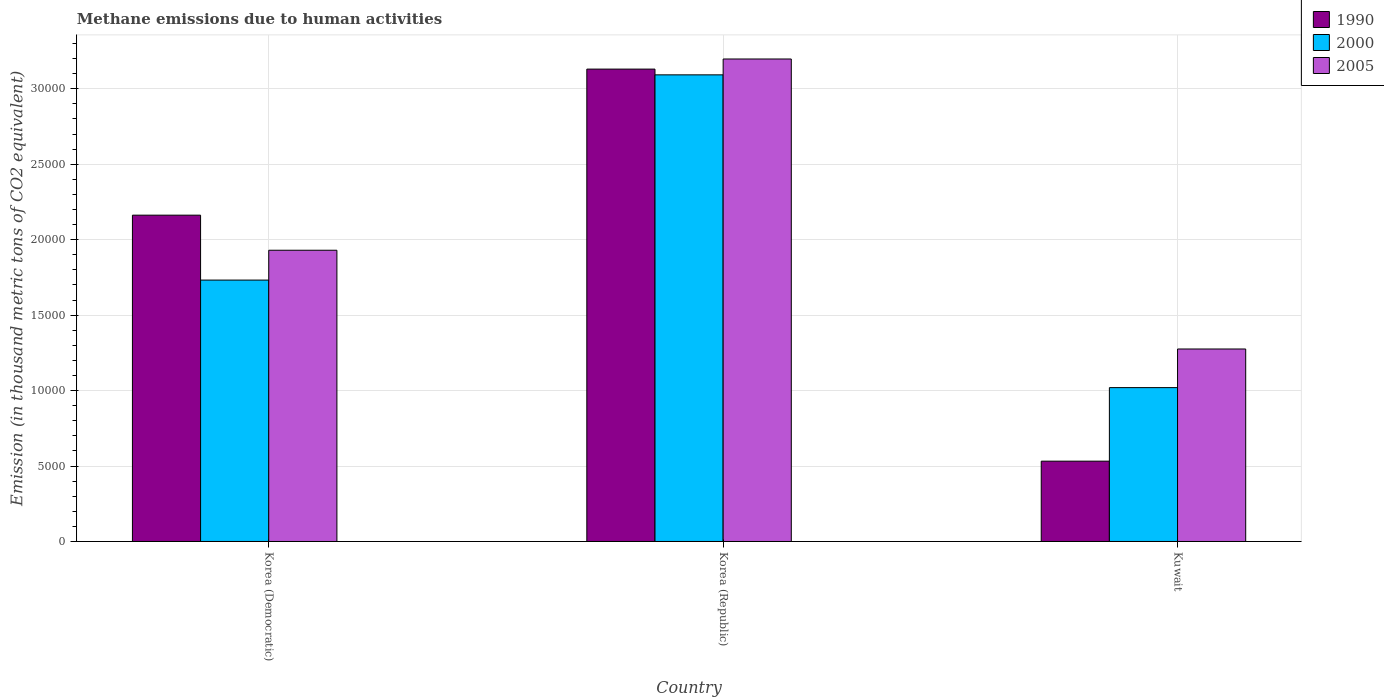How many different coloured bars are there?
Provide a succinct answer. 3. Are the number of bars per tick equal to the number of legend labels?
Keep it short and to the point. Yes. Are the number of bars on each tick of the X-axis equal?
Give a very brief answer. Yes. How many bars are there on the 3rd tick from the left?
Ensure brevity in your answer.  3. What is the label of the 3rd group of bars from the left?
Make the answer very short. Kuwait. What is the amount of methane emitted in 1990 in Korea (Republic)?
Provide a succinct answer. 3.13e+04. Across all countries, what is the maximum amount of methane emitted in 2005?
Your answer should be very brief. 3.20e+04. Across all countries, what is the minimum amount of methane emitted in 2000?
Provide a short and direct response. 1.02e+04. In which country was the amount of methane emitted in 2005 minimum?
Offer a very short reply. Kuwait. What is the total amount of methane emitted in 2005 in the graph?
Your answer should be very brief. 6.40e+04. What is the difference between the amount of methane emitted in 1990 in Korea (Democratic) and that in Korea (Republic)?
Ensure brevity in your answer.  -9680.3. What is the difference between the amount of methane emitted in 2000 in Kuwait and the amount of methane emitted in 2005 in Korea (Democratic)?
Provide a succinct answer. -9104.1. What is the average amount of methane emitted in 1990 per country?
Offer a terse response. 1.94e+04. What is the difference between the amount of methane emitted of/in 1990 and amount of methane emitted of/in 2000 in Korea (Democratic)?
Make the answer very short. 4301.8. In how many countries, is the amount of methane emitted in 1990 greater than 8000 thousand metric tons?
Provide a short and direct response. 2. What is the ratio of the amount of methane emitted in 2005 in Korea (Democratic) to that in Kuwait?
Ensure brevity in your answer.  1.51. Is the difference between the amount of methane emitted in 1990 in Korea (Democratic) and Kuwait greater than the difference between the amount of methane emitted in 2000 in Korea (Democratic) and Kuwait?
Provide a short and direct response. Yes. What is the difference between the highest and the second highest amount of methane emitted in 1990?
Provide a short and direct response. -9680.3. What is the difference between the highest and the lowest amount of methane emitted in 2005?
Your answer should be very brief. 1.92e+04. Is the sum of the amount of methane emitted in 2005 in Korea (Democratic) and Kuwait greater than the maximum amount of methane emitted in 2000 across all countries?
Keep it short and to the point. Yes. What does the 3rd bar from the left in Korea (Democratic) represents?
Ensure brevity in your answer.  2005. What does the 3rd bar from the right in Korea (Democratic) represents?
Your answer should be compact. 1990. How many bars are there?
Your response must be concise. 9. How many countries are there in the graph?
Make the answer very short. 3. What is the difference between two consecutive major ticks on the Y-axis?
Your answer should be compact. 5000. Are the values on the major ticks of Y-axis written in scientific E-notation?
Keep it short and to the point. No. Does the graph contain any zero values?
Ensure brevity in your answer.  No. Where does the legend appear in the graph?
Keep it short and to the point. Top right. How are the legend labels stacked?
Your answer should be very brief. Vertical. What is the title of the graph?
Your answer should be very brief. Methane emissions due to human activities. Does "1999" appear as one of the legend labels in the graph?
Your answer should be very brief. No. What is the label or title of the Y-axis?
Offer a terse response. Emission (in thousand metric tons of CO2 equivalent). What is the Emission (in thousand metric tons of CO2 equivalent) of 1990 in Korea (Democratic)?
Ensure brevity in your answer.  2.16e+04. What is the Emission (in thousand metric tons of CO2 equivalent) in 2000 in Korea (Democratic)?
Offer a terse response. 1.73e+04. What is the Emission (in thousand metric tons of CO2 equivalent) in 2005 in Korea (Democratic)?
Offer a terse response. 1.93e+04. What is the Emission (in thousand metric tons of CO2 equivalent) in 1990 in Korea (Republic)?
Make the answer very short. 3.13e+04. What is the Emission (in thousand metric tons of CO2 equivalent) in 2000 in Korea (Republic)?
Offer a very short reply. 3.09e+04. What is the Emission (in thousand metric tons of CO2 equivalent) in 2005 in Korea (Republic)?
Provide a succinct answer. 3.20e+04. What is the Emission (in thousand metric tons of CO2 equivalent) of 1990 in Kuwait?
Your response must be concise. 5323.1. What is the Emission (in thousand metric tons of CO2 equivalent) in 2000 in Kuwait?
Your answer should be very brief. 1.02e+04. What is the Emission (in thousand metric tons of CO2 equivalent) in 2005 in Kuwait?
Your answer should be compact. 1.28e+04. Across all countries, what is the maximum Emission (in thousand metric tons of CO2 equivalent) of 1990?
Keep it short and to the point. 3.13e+04. Across all countries, what is the maximum Emission (in thousand metric tons of CO2 equivalent) of 2000?
Provide a short and direct response. 3.09e+04. Across all countries, what is the maximum Emission (in thousand metric tons of CO2 equivalent) of 2005?
Keep it short and to the point. 3.20e+04. Across all countries, what is the minimum Emission (in thousand metric tons of CO2 equivalent) in 1990?
Ensure brevity in your answer.  5323.1. Across all countries, what is the minimum Emission (in thousand metric tons of CO2 equivalent) in 2000?
Offer a very short reply. 1.02e+04. Across all countries, what is the minimum Emission (in thousand metric tons of CO2 equivalent) in 2005?
Give a very brief answer. 1.28e+04. What is the total Emission (in thousand metric tons of CO2 equivalent) in 1990 in the graph?
Provide a succinct answer. 5.83e+04. What is the total Emission (in thousand metric tons of CO2 equivalent) of 2000 in the graph?
Give a very brief answer. 5.84e+04. What is the total Emission (in thousand metric tons of CO2 equivalent) of 2005 in the graph?
Provide a short and direct response. 6.40e+04. What is the difference between the Emission (in thousand metric tons of CO2 equivalent) of 1990 in Korea (Democratic) and that in Korea (Republic)?
Your answer should be very brief. -9680.3. What is the difference between the Emission (in thousand metric tons of CO2 equivalent) in 2000 in Korea (Democratic) and that in Korea (Republic)?
Make the answer very short. -1.36e+04. What is the difference between the Emission (in thousand metric tons of CO2 equivalent) of 2005 in Korea (Democratic) and that in Korea (Republic)?
Give a very brief answer. -1.27e+04. What is the difference between the Emission (in thousand metric tons of CO2 equivalent) of 1990 in Korea (Democratic) and that in Kuwait?
Your answer should be very brief. 1.63e+04. What is the difference between the Emission (in thousand metric tons of CO2 equivalent) in 2000 in Korea (Democratic) and that in Kuwait?
Give a very brief answer. 7127.1. What is the difference between the Emission (in thousand metric tons of CO2 equivalent) in 2005 in Korea (Democratic) and that in Kuwait?
Your answer should be compact. 6544.1. What is the difference between the Emission (in thousand metric tons of CO2 equivalent) of 1990 in Korea (Republic) and that in Kuwait?
Ensure brevity in your answer.  2.60e+04. What is the difference between the Emission (in thousand metric tons of CO2 equivalent) in 2000 in Korea (Republic) and that in Kuwait?
Keep it short and to the point. 2.07e+04. What is the difference between the Emission (in thousand metric tons of CO2 equivalent) in 2005 in Korea (Republic) and that in Kuwait?
Your response must be concise. 1.92e+04. What is the difference between the Emission (in thousand metric tons of CO2 equivalent) in 1990 in Korea (Democratic) and the Emission (in thousand metric tons of CO2 equivalent) in 2000 in Korea (Republic)?
Offer a terse response. -9299.2. What is the difference between the Emission (in thousand metric tons of CO2 equivalent) in 1990 in Korea (Democratic) and the Emission (in thousand metric tons of CO2 equivalent) in 2005 in Korea (Republic)?
Make the answer very short. -1.04e+04. What is the difference between the Emission (in thousand metric tons of CO2 equivalent) of 2000 in Korea (Democratic) and the Emission (in thousand metric tons of CO2 equivalent) of 2005 in Korea (Republic)?
Your answer should be very brief. -1.47e+04. What is the difference between the Emission (in thousand metric tons of CO2 equivalent) of 1990 in Korea (Democratic) and the Emission (in thousand metric tons of CO2 equivalent) of 2000 in Kuwait?
Offer a terse response. 1.14e+04. What is the difference between the Emission (in thousand metric tons of CO2 equivalent) in 1990 in Korea (Democratic) and the Emission (in thousand metric tons of CO2 equivalent) in 2005 in Kuwait?
Keep it short and to the point. 8868.9. What is the difference between the Emission (in thousand metric tons of CO2 equivalent) in 2000 in Korea (Democratic) and the Emission (in thousand metric tons of CO2 equivalent) in 2005 in Kuwait?
Ensure brevity in your answer.  4567.1. What is the difference between the Emission (in thousand metric tons of CO2 equivalent) of 1990 in Korea (Republic) and the Emission (in thousand metric tons of CO2 equivalent) of 2000 in Kuwait?
Provide a short and direct response. 2.11e+04. What is the difference between the Emission (in thousand metric tons of CO2 equivalent) in 1990 in Korea (Republic) and the Emission (in thousand metric tons of CO2 equivalent) in 2005 in Kuwait?
Your answer should be very brief. 1.85e+04. What is the difference between the Emission (in thousand metric tons of CO2 equivalent) in 2000 in Korea (Republic) and the Emission (in thousand metric tons of CO2 equivalent) in 2005 in Kuwait?
Offer a very short reply. 1.82e+04. What is the average Emission (in thousand metric tons of CO2 equivalent) of 1990 per country?
Offer a terse response. 1.94e+04. What is the average Emission (in thousand metric tons of CO2 equivalent) in 2000 per country?
Give a very brief answer. 1.95e+04. What is the average Emission (in thousand metric tons of CO2 equivalent) of 2005 per country?
Provide a succinct answer. 2.13e+04. What is the difference between the Emission (in thousand metric tons of CO2 equivalent) in 1990 and Emission (in thousand metric tons of CO2 equivalent) in 2000 in Korea (Democratic)?
Your answer should be very brief. 4301.8. What is the difference between the Emission (in thousand metric tons of CO2 equivalent) of 1990 and Emission (in thousand metric tons of CO2 equivalent) of 2005 in Korea (Democratic)?
Provide a short and direct response. 2324.8. What is the difference between the Emission (in thousand metric tons of CO2 equivalent) of 2000 and Emission (in thousand metric tons of CO2 equivalent) of 2005 in Korea (Democratic)?
Ensure brevity in your answer.  -1977. What is the difference between the Emission (in thousand metric tons of CO2 equivalent) in 1990 and Emission (in thousand metric tons of CO2 equivalent) in 2000 in Korea (Republic)?
Keep it short and to the point. 381.1. What is the difference between the Emission (in thousand metric tons of CO2 equivalent) of 1990 and Emission (in thousand metric tons of CO2 equivalent) of 2005 in Korea (Republic)?
Ensure brevity in your answer.  -669.8. What is the difference between the Emission (in thousand metric tons of CO2 equivalent) in 2000 and Emission (in thousand metric tons of CO2 equivalent) in 2005 in Korea (Republic)?
Ensure brevity in your answer.  -1050.9. What is the difference between the Emission (in thousand metric tons of CO2 equivalent) in 1990 and Emission (in thousand metric tons of CO2 equivalent) in 2000 in Kuwait?
Provide a short and direct response. -4873.7. What is the difference between the Emission (in thousand metric tons of CO2 equivalent) of 1990 and Emission (in thousand metric tons of CO2 equivalent) of 2005 in Kuwait?
Offer a very short reply. -7433.7. What is the difference between the Emission (in thousand metric tons of CO2 equivalent) in 2000 and Emission (in thousand metric tons of CO2 equivalent) in 2005 in Kuwait?
Provide a short and direct response. -2560. What is the ratio of the Emission (in thousand metric tons of CO2 equivalent) of 1990 in Korea (Democratic) to that in Korea (Republic)?
Provide a short and direct response. 0.69. What is the ratio of the Emission (in thousand metric tons of CO2 equivalent) in 2000 in Korea (Democratic) to that in Korea (Republic)?
Your answer should be very brief. 0.56. What is the ratio of the Emission (in thousand metric tons of CO2 equivalent) in 2005 in Korea (Democratic) to that in Korea (Republic)?
Offer a terse response. 0.6. What is the ratio of the Emission (in thousand metric tons of CO2 equivalent) in 1990 in Korea (Democratic) to that in Kuwait?
Make the answer very short. 4.06. What is the ratio of the Emission (in thousand metric tons of CO2 equivalent) of 2000 in Korea (Democratic) to that in Kuwait?
Your answer should be very brief. 1.7. What is the ratio of the Emission (in thousand metric tons of CO2 equivalent) of 2005 in Korea (Democratic) to that in Kuwait?
Provide a succinct answer. 1.51. What is the ratio of the Emission (in thousand metric tons of CO2 equivalent) of 1990 in Korea (Republic) to that in Kuwait?
Offer a very short reply. 5.88. What is the ratio of the Emission (in thousand metric tons of CO2 equivalent) in 2000 in Korea (Republic) to that in Kuwait?
Give a very brief answer. 3.03. What is the ratio of the Emission (in thousand metric tons of CO2 equivalent) in 2005 in Korea (Republic) to that in Kuwait?
Make the answer very short. 2.51. What is the difference between the highest and the second highest Emission (in thousand metric tons of CO2 equivalent) of 1990?
Provide a succinct answer. 9680.3. What is the difference between the highest and the second highest Emission (in thousand metric tons of CO2 equivalent) in 2000?
Provide a succinct answer. 1.36e+04. What is the difference between the highest and the second highest Emission (in thousand metric tons of CO2 equivalent) of 2005?
Give a very brief answer. 1.27e+04. What is the difference between the highest and the lowest Emission (in thousand metric tons of CO2 equivalent) in 1990?
Provide a short and direct response. 2.60e+04. What is the difference between the highest and the lowest Emission (in thousand metric tons of CO2 equivalent) of 2000?
Your response must be concise. 2.07e+04. What is the difference between the highest and the lowest Emission (in thousand metric tons of CO2 equivalent) of 2005?
Your response must be concise. 1.92e+04. 